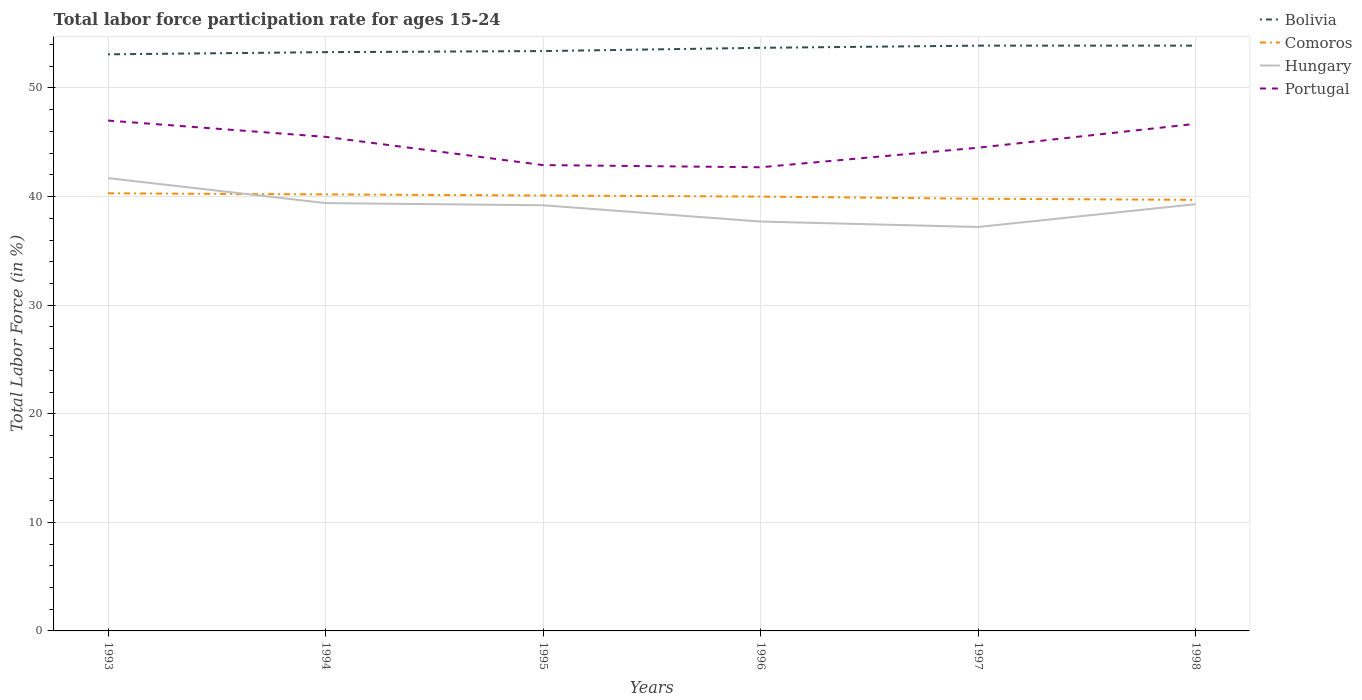How many different coloured lines are there?
Your answer should be compact. 4. Is the number of lines equal to the number of legend labels?
Your answer should be very brief. Yes. Across all years, what is the maximum labor force participation rate in Hungary?
Provide a short and direct response. 37.2. In which year was the labor force participation rate in Comoros maximum?
Your answer should be very brief. 1998. What is the total labor force participation rate in Hungary in the graph?
Make the answer very short. 1.5. What is the difference between the highest and the second highest labor force participation rate in Hungary?
Give a very brief answer. 4.5. How many lines are there?
Provide a succinct answer. 4. Does the graph contain any zero values?
Your response must be concise. No. How many legend labels are there?
Provide a succinct answer. 4. How are the legend labels stacked?
Your answer should be very brief. Vertical. What is the title of the graph?
Give a very brief answer. Total labor force participation rate for ages 15-24. Does "Macedonia" appear as one of the legend labels in the graph?
Your answer should be compact. No. What is the label or title of the Y-axis?
Offer a very short reply. Total Labor Force (in %). What is the Total Labor Force (in %) in Bolivia in 1993?
Keep it short and to the point. 53.1. What is the Total Labor Force (in %) of Comoros in 1993?
Offer a terse response. 40.3. What is the Total Labor Force (in %) of Hungary in 1993?
Offer a very short reply. 41.7. What is the Total Labor Force (in %) in Bolivia in 1994?
Make the answer very short. 53.3. What is the Total Labor Force (in %) in Comoros in 1994?
Provide a short and direct response. 40.2. What is the Total Labor Force (in %) in Hungary in 1994?
Your answer should be very brief. 39.4. What is the Total Labor Force (in %) of Portugal in 1994?
Offer a terse response. 45.5. What is the Total Labor Force (in %) of Bolivia in 1995?
Make the answer very short. 53.4. What is the Total Labor Force (in %) of Comoros in 1995?
Provide a short and direct response. 40.1. What is the Total Labor Force (in %) in Hungary in 1995?
Your answer should be compact. 39.2. What is the Total Labor Force (in %) in Portugal in 1995?
Provide a short and direct response. 42.9. What is the Total Labor Force (in %) in Bolivia in 1996?
Your answer should be very brief. 53.7. What is the Total Labor Force (in %) in Hungary in 1996?
Give a very brief answer. 37.7. What is the Total Labor Force (in %) of Portugal in 1996?
Offer a very short reply. 42.7. What is the Total Labor Force (in %) in Bolivia in 1997?
Your response must be concise. 53.9. What is the Total Labor Force (in %) in Comoros in 1997?
Ensure brevity in your answer.  39.8. What is the Total Labor Force (in %) in Hungary in 1997?
Your answer should be very brief. 37.2. What is the Total Labor Force (in %) of Portugal in 1997?
Offer a very short reply. 44.5. What is the Total Labor Force (in %) of Bolivia in 1998?
Make the answer very short. 53.9. What is the Total Labor Force (in %) of Comoros in 1998?
Give a very brief answer. 39.7. What is the Total Labor Force (in %) in Hungary in 1998?
Make the answer very short. 39.3. What is the Total Labor Force (in %) of Portugal in 1998?
Keep it short and to the point. 46.7. Across all years, what is the maximum Total Labor Force (in %) of Bolivia?
Your answer should be very brief. 53.9. Across all years, what is the maximum Total Labor Force (in %) of Comoros?
Give a very brief answer. 40.3. Across all years, what is the maximum Total Labor Force (in %) of Hungary?
Ensure brevity in your answer.  41.7. Across all years, what is the maximum Total Labor Force (in %) in Portugal?
Your answer should be very brief. 47. Across all years, what is the minimum Total Labor Force (in %) of Bolivia?
Ensure brevity in your answer.  53.1. Across all years, what is the minimum Total Labor Force (in %) in Comoros?
Give a very brief answer. 39.7. Across all years, what is the minimum Total Labor Force (in %) in Hungary?
Make the answer very short. 37.2. Across all years, what is the minimum Total Labor Force (in %) in Portugal?
Ensure brevity in your answer.  42.7. What is the total Total Labor Force (in %) in Bolivia in the graph?
Your response must be concise. 321.3. What is the total Total Labor Force (in %) of Comoros in the graph?
Your answer should be compact. 240.1. What is the total Total Labor Force (in %) of Hungary in the graph?
Ensure brevity in your answer.  234.5. What is the total Total Labor Force (in %) of Portugal in the graph?
Ensure brevity in your answer.  269.3. What is the difference between the Total Labor Force (in %) of Hungary in 1993 and that in 1994?
Offer a very short reply. 2.3. What is the difference between the Total Labor Force (in %) of Portugal in 1993 and that in 1994?
Provide a short and direct response. 1.5. What is the difference between the Total Labor Force (in %) of Bolivia in 1993 and that in 1995?
Keep it short and to the point. -0.3. What is the difference between the Total Labor Force (in %) of Comoros in 1993 and that in 1995?
Your response must be concise. 0.2. What is the difference between the Total Labor Force (in %) of Hungary in 1993 and that in 1995?
Provide a short and direct response. 2.5. What is the difference between the Total Labor Force (in %) in Comoros in 1993 and that in 1996?
Your answer should be compact. 0.3. What is the difference between the Total Labor Force (in %) in Hungary in 1993 and that in 1996?
Provide a succinct answer. 4. What is the difference between the Total Labor Force (in %) in Portugal in 1993 and that in 1996?
Your answer should be very brief. 4.3. What is the difference between the Total Labor Force (in %) in Bolivia in 1993 and that in 1997?
Ensure brevity in your answer.  -0.8. What is the difference between the Total Labor Force (in %) of Comoros in 1993 and that in 1997?
Keep it short and to the point. 0.5. What is the difference between the Total Labor Force (in %) of Hungary in 1993 and that in 1997?
Provide a short and direct response. 4.5. What is the difference between the Total Labor Force (in %) in Comoros in 1993 and that in 1998?
Keep it short and to the point. 0.6. What is the difference between the Total Labor Force (in %) in Portugal in 1993 and that in 1998?
Provide a short and direct response. 0.3. What is the difference between the Total Labor Force (in %) of Bolivia in 1994 and that in 1995?
Make the answer very short. -0.1. What is the difference between the Total Labor Force (in %) of Comoros in 1994 and that in 1995?
Your answer should be very brief. 0.1. What is the difference between the Total Labor Force (in %) of Portugal in 1994 and that in 1995?
Make the answer very short. 2.6. What is the difference between the Total Labor Force (in %) of Hungary in 1994 and that in 1996?
Make the answer very short. 1.7. What is the difference between the Total Labor Force (in %) of Portugal in 1994 and that in 1997?
Your response must be concise. 1. What is the difference between the Total Labor Force (in %) of Bolivia in 1994 and that in 1998?
Make the answer very short. -0.6. What is the difference between the Total Labor Force (in %) of Hungary in 1994 and that in 1998?
Give a very brief answer. 0.1. What is the difference between the Total Labor Force (in %) in Portugal in 1994 and that in 1998?
Your answer should be very brief. -1.2. What is the difference between the Total Labor Force (in %) in Comoros in 1995 and that in 1996?
Ensure brevity in your answer.  0.1. What is the difference between the Total Labor Force (in %) in Portugal in 1995 and that in 1997?
Your answer should be compact. -1.6. What is the difference between the Total Labor Force (in %) of Portugal in 1995 and that in 1998?
Offer a terse response. -3.8. What is the difference between the Total Labor Force (in %) of Bolivia in 1996 and that in 1997?
Provide a short and direct response. -0.2. What is the difference between the Total Labor Force (in %) in Comoros in 1996 and that in 1997?
Give a very brief answer. 0.2. What is the difference between the Total Labor Force (in %) of Hungary in 1996 and that in 1997?
Make the answer very short. 0.5. What is the difference between the Total Labor Force (in %) in Bolivia in 1996 and that in 1998?
Provide a short and direct response. -0.2. What is the difference between the Total Labor Force (in %) in Comoros in 1996 and that in 1998?
Your answer should be compact. 0.3. What is the difference between the Total Labor Force (in %) in Hungary in 1996 and that in 1998?
Keep it short and to the point. -1.6. What is the difference between the Total Labor Force (in %) in Bolivia in 1997 and that in 1998?
Keep it short and to the point. 0. What is the difference between the Total Labor Force (in %) of Hungary in 1997 and that in 1998?
Provide a short and direct response. -2.1. What is the difference between the Total Labor Force (in %) of Portugal in 1997 and that in 1998?
Your answer should be compact. -2.2. What is the difference between the Total Labor Force (in %) in Bolivia in 1993 and the Total Labor Force (in %) in Hungary in 1994?
Offer a terse response. 13.7. What is the difference between the Total Labor Force (in %) of Hungary in 1993 and the Total Labor Force (in %) of Portugal in 1994?
Ensure brevity in your answer.  -3.8. What is the difference between the Total Labor Force (in %) of Bolivia in 1993 and the Total Labor Force (in %) of Comoros in 1995?
Offer a very short reply. 13. What is the difference between the Total Labor Force (in %) in Bolivia in 1993 and the Total Labor Force (in %) in Hungary in 1995?
Give a very brief answer. 13.9. What is the difference between the Total Labor Force (in %) of Bolivia in 1993 and the Total Labor Force (in %) of Portugal in 1995?
Give a very brief answer. 10.2. What is the difference between the Total Labor Force (in %) in Comoros in 1993 and the Total Labor Force (in %) in Hungary in 1995?
Your answer should be very brief. 1.1. What is the difference between the Total Labor Force (in %) in Comoros in 1993 and the Total Labor Force (in %) in Portugal in 1995?
Provide a short and direct response. -2.6. What is the difference between the Total Labor Force (in %) in Bolivia in 1993 and the Total Labor Force (in %) in Portugal in 1996?
Offer a terse response. 10.4. What is the difference between the Total Labor Force (in %) of Comoros in 1993 and the Total Labor Force (in %) of Hungary in 1996?
Provide a short and direct response. 2.6. What is the difference between the Total Labor Force (in %) in Hungary in 1993 and the Total Labor Force (in %) in Portugal in 1997?
Offer a terse response. -2.8. What is the difference between the Total Labor Force (in %) of Bolivia in 1993 and the Total Labor Force (in %) of Hungary in 1998?
Offer a terse response. 13.8. What is the difference between the Total Labor Force (in %) in Hungary in 1993 and the Total Labor Force (in %) in Portugal in 1998?
Your answer should be compact. -5. What is the difference between the Total Labor Force (in %) in Bolivia in 1994 and the Total Labor Force (in %) in Comoros in 1995?
Ensure brevity in your answer.  13.2. What is the difference between the Total Labor Force (in %) of Comoros in 1994 and the Total Labor Force (in %) of Hungary in 1995?
Provide a succinct answer. 1. What is the difference between the Total Labor Force (in %) of Bolivia in 1994 and the Total Labor Force (in %) of Comoros in 1996?
Ensure brevity in your answer.  13.3. What is the difference between the Total Labor Force (in %) of Bolivia in 1994 and the Total Labor Force (in %) of Hungary in 1996?
Your answer should be very brief. 15.6. What is the difference between the Total Labor Force (in %) in Bolivia in 1994 and the Total Labor Force (in %) in Portugal in 1996?
Make the answer very short. 10.6. What is the difference between the Total Labor Force (in %) of Comoros in 1994 and the Total Labor Force (in %) of Hungary in 1996?
Ensure brevity in your answer.  2.5. What is the difference between the Total Labor Force (in %) of Hungary in 1994 and the Total Labor Force (in %) of Portugal in 1996?
Your answer should be very brief. -3.3. What is the difference between the Total Labor Force (in %) in Bolivia in 1994 and the Total Labor Force (in %) in Comoros in 1997?
Your response must be concise. 13.5. What is the difference between the Total Labor Force (in %) in Bolivia in 1994 and the Total Labor Force (in %) in Portugal in 1997?
Offer a very short reply. 8.8. What is the difference between the Total Labor Force (in %) of Comoros in 1994 and the Total Labor Force (in %) of Portugal in 1997?
Make the answer very short. -4.3. What is the difference between the Total Labor Force (in %) of Bolivia in 1994 and the Total Labor Force (in %) of Hungary in 1998?
Your answer should be very brief. 14. What is the difference between the Total Labor Force (in %) in Bolivia in 1995 and the Total Labor Force (in %) in Comoros in 1996?
Offer a very short reply. 13.4. What is the difference between the Total Labor Force (in %) in Bolivia in 1995 and the Total Labor Force (in %) in Portugal in 1996?
Your answer should be compact. 10.7. What is the difference between the Total Labor Force (in %) in Comoros in 1995 and the Total Labor Force (in %) in Hungary in 1996?
Provide a short and direct response. 2.4. What is the difference between the Total Labor Force (in %) in Bolivia in 1995 and the Total Labor Force (in %) in Comoros in 1997?
Give a very brief answer. 13.6. What is the difference between the Total Labor Force (in %) of Bolivia in 1995 and the Total Labor Force (in %) of Hungary in 1997?
Your answer should be very brief. 16.2. What is the difference between the Total Labor Force (in %) of Comoros in 1995 and the Total Labor Force (in %) of Portugal in 1997?
Provide a short and direct response. -4.4. What is the difference between the Total Labor Force (in %) in Hungary in 1995 and the Total Labor Force (in %) in Portugal in 1997?
Keep it short and to the point. -5.3. What is the difference between the Total Labor Force (in %) of Bolivia in 1995 and the Total Labor Force (in %) of Hungary in 1998?
Offer a terse response. 14.1. What is the difference between the Total Labor Force (in %) in Comoros in 1995 and the Total Labor Force (in %) in Hungary in 1998?
Provide a short and direct response. 0.8. What is the difference between the Total Labor Force (in %) of Bolivia in 1996 and the Total Labor Force (in %) of Comoros in 1998?
Your response must be concise. 14. What is the difference between the Total Labor Force (in %) in Hungary in 1996 and the Total Labor Force (in %) in Portugal in 1998?
Provide a short and direct response. -9. What is the difference between the Total Labor Force (in %) of Bolivia in 1997 and the Total Labor Force (in %) of Comoros in 1998?
Make the answer very short. 14.2. What is the difference between the Total Labor Force (in %) of Bolivia in 1997 and the Total Labor Force (in %) of Hungary in 1998?
Keep it short and to the point. 14.6. What is the difference between the Total Labor Force (in %) of Bolivia in 1997 and the Total Labor Force (in %) of Portugal in 1998?
Your response must be concise. 7.2. What is the average Total Labor Force (in %) in Bolivia per year?
Offer a very short reply. 53.55. What is the average Total Labor Force (in %) of Comoros per year?
Ensure brevity in your answer.  40.02. What is the average Total Labor Force (in %) in Hungary per year?
Offer a very short reply. 39.08. What is the average Total Labor Force (in %) in Portugal per year?
Ensure brevity in your answer.  44.88. In the year 1993, what is the difference between the Total Labor Force (in %) of Comoros and Total Labor Force (in %) of Hungary?
Ensure brevity in your answer.  -1.4. In the year 1994, what is the difference between the Total Labor Force (in %) in Bolivia and Total Labor Force (in %) in Comoros?
Provide a short and direct response. 13.1. In the year 1994, what is the difference between the Total Labor Force (in %) in Bolivia and Total Labor Force (in %) in Hungary?
Make the answer very short. 13.9. In the year 1994, what is the difference between the Total Labor Force (in %) of Bolivia and Total Labor Force (in %) of Portugal?
Offer a terse response. 7.8. In the year 1995, what is the difference between the Total Labor Force (in %) in Bolivia and Total Labor Force (in %) in Comoros?
Keep it short and to the point. 13.3. In the year 1995, what is the difference between the Total Labor Force (in %) of Comoros and Total Labor Force (in %) of Hungary?
Keep it short and to the point. 0.9. In the year 1996, what is the difference between the Total Labor Force (in %) in Bolivia and Total Labor Force (in %) in Comoros?
Provide a succinct answer. 13.7. In the year 1996, what is the difference between the Total Labor Force (in %) of Bolivia and Total Labor Force (in %) of Portugal?
Provide a short and direct response. 11. In the year 1996, what is the difference between the Total Labor Force (in %) of Comoros and Total Labor Force (in %) of Hungary?
Provide a short and direct response. 2.3. In the year 1996, what is the difference between the Total Labor Force (in %) of Hungary and Total Labor Force (in %) of Portugal?
Offer a terse response. -5. In the year 1997, what is the difference between the Total Labor Force (in %) in Bolivia and Total Labor Force (in %) in Portugal?
Provide a short and direct response. 9.4. In the year 1998, what is the difference between the Total Labor Force (in %) of Bolivia and Total Labor Force (in %) of Portugal?
Your response must be concise. 7.2. In the year 1998, what is the difference between the Total Labor Force (in %) in Comoros and Total Labor Force (in %) in Portugal?
Keep it short and to the point. -7. What is the ratio of the Total Labor Force (in %) in Bolivia in 1993 to that in 1994?
Your response must be concise. 1. What is the ratio of the Total Labor Force (in %) of Comoros in 1993 to that in 1994?
Your response must be concise. 1. What is the ratio of the Total Labor Force (in %) in Hungary in 1993 to that in 1994?
Your answer should be compact. 1.06. What is the ratio of the Total Labor Force (in %) of Portugal in 1993 to that in 1994?
Your answer should be compact. 1.03. What is the ratio of the Total Labor Force (in %) of Comoros in 1993 to that in 1995?
Ensure brevity in your answer.  1. What is the ratio of the Total Labor Force (in %) in Hungary in 1993 to that in 1995?
Your answer should be compact. 1.06. What is the ratio of the Total Labor Force (in %) of Portugal in 1993 to that in 1995?
Your answer should be compact. 1.1. What is the ratio of the Total Labor Force (in %) in Bolivia in 1993 to that in 1996?
Offer a very short reply. 0.99. What is the ratio of the Total Labor Force (in %) in Comoros in 1993 to that in 1996?
Ensure brevity in your answer.  1.01. What is the ratio of the Total Labor Force (in %) of Hungary in 1993 to that in 1996?
Keep it short and to the point. 1.11. What is the ratio of the Total Labor Force (in %) of Portugal in 1993 to that in 1996?
Your response must be concise. 1.1. What is the ratio of the Total Labor Force (in %) in Bolivia in 1993 to that in 1997?
Provide a succinct answer. 0.99. What is the ratio of the Total Labor Force (in %) in Comoros in 1993 to that in 1997?
Provide a succinct answer. 1.01. What is the ratio of the Total Labor Force (in %) in Hungary in 1993 to that in 1997?
Offer a terse response. 1.12. What is the ratio of the Total Labor Force (in %) of Portugal in 1993 to that in 1997?
Your response must be concise. 1.06. What is the ratio of the Total Labor Force (in %) of Bolivia in 1993 to that in 1998?
Your response must be concise. 0.99. What is the ratio of the Total Labor Force (in %) of Comoros in 1993 to that in 1998?
Provide a short and direct response. 1.02. What is the ratio of the Total Labor Force (in %) of Hungary in 1993 to that in 1998?
Offer a very short reply. 1.06. What is the ratio of the Total Labor Force (in %) of Portugal in 1993 to that in 1998?
Provide a succinct answer. 1.01. What is the ratio of the Total Labor Force (in %) in Hungary in 1994 to that in 1995?
Provide a succinct answer. 1.01. What is the ratio of the Total Labor Force (in %) of Portugal in 1994 to that in 1995?
Give a very brief answer. 1.06. What is the ratio of the Total Labor Force (in %) of Hungary in 1994 to that in 1996?
Your answer should be compact. 1.05. What is the ratio of the Total Labor Force (in %) of Portugal in 1994 to that in 1996?
Offer a terse response. 1.07. What is the ratio of the Total Labor Force (in %) of Bolivia in 1994 to that in 1997?
Your answer should be compact. 0.99. What is the ratio of the Total Labor Force (in %) in Comoros in 1994 to that in 1997?
Give a very brief answer. 1.01. What is the ratio of the Total Labor Force (in %) in Hungary in 1994 to that in 1997?
Make the answer very short. 1.06. What is the ratio of the Total Labor Force (in %) in Portugal in 1994 to that in 1997?
Your answer should be compact. 1.02. What is the ratio of the Total Labor Force (in %) in Bolivia in 1994 to that in 1998?
Your answer should be compact. 0.99. What is the ratio of the Total Labor Force (in %) in Comoros in 1994 to that in 1998?
Make the answer very short. 1.01. What is the ratio of the Total Labor Force (in %) of Portugal in 1994 to that in 1998?
Your answer should be very brief. 0.97. What is the ratio of the Total Labor Force (in %) in Bolivia in 1995 to that in 1996?
Offer a very short reply. 0.99. What is the ratio of the Total Labor Force (in %) in Hungary in 1995 to that in 1996?
Offer a terse response. 1.04. What is the ratio of the Total Labor Force (in %) of Bolivia in 1995 to that in 1997?
Keep it short and to the point. 0.99. What is the ratio of the Total Labor Force (in %) in Comoros in 1995 to that in 1997?
Ensure brevity in your answer.  1.01. What is the ratio of the Total Labor Force (in %) of Hungary in 1995 to that in 1997?
Offer a very short reply. 1.05. What is the ratio of the Total Labor Force (in %) of Comoros in 1995 to that in 1998?
Your answer should be compact. 1.01. What is the ratio of the Total Labor Force (in %) in Hungary in 1995 to that in 1998?
Your answer should be very brief. 1. What is the ratio of the Total Labor Force (in %) in Portugal in 1995 to that in 1998?
Offer a terse response. 0.92. What is the ratio of the Total Labor Force (in %) of Hungary in 1996 to that in 1997?
Give a very brief answer. 1.01. What is the ratio of the Total Labor Force (in %) in Portugal in 1996 to that in 1997?
Your response must be concise. 0.96. What is the ratio of the Total Labor Force (in %) of Comoros in 1996 to that in 1998?
Provide a short and direct response. 1.01. What is the ratio of the Total Labor Force (in %) of Hungary in 1996 to that in 1998?
Offer a very short reply. 0.96. What is the ratio of the Total Labor Force (in %) of Portugal in 1996 to that in 1998?
Make the answer very short. 0.91. What is the ratio of the Total Labor Force (in %) of Hungary in 1997 to that in 1998?
Your answer should be compact. 0.95. What is the ratio of the Total Labor Force (in %) of Portugal in 1997 to that in 1998?
Keep it short and to the point. 0.95. What is the difference between the highest and the second highest Total Labor Force (in %) of Bolivia?
Make the answer very short. 0. What is the difference between the highest and the second highest Total Labor Force (in %) of Portugal?
Your answer should be very brief. 0.3. What is the difference between the highest and the lowest Total Labor Force (in %) of Bolivia?
Offer a terse response. 0.8. What is the difference between the highest and the lowest Total Labor Force (in %) in Comoros?
Your response must be concise. 0.6. What is the difference between the highest and the lowest Total Labor Force (in %) in Hungary?
Make the answer very short. 4.5. 